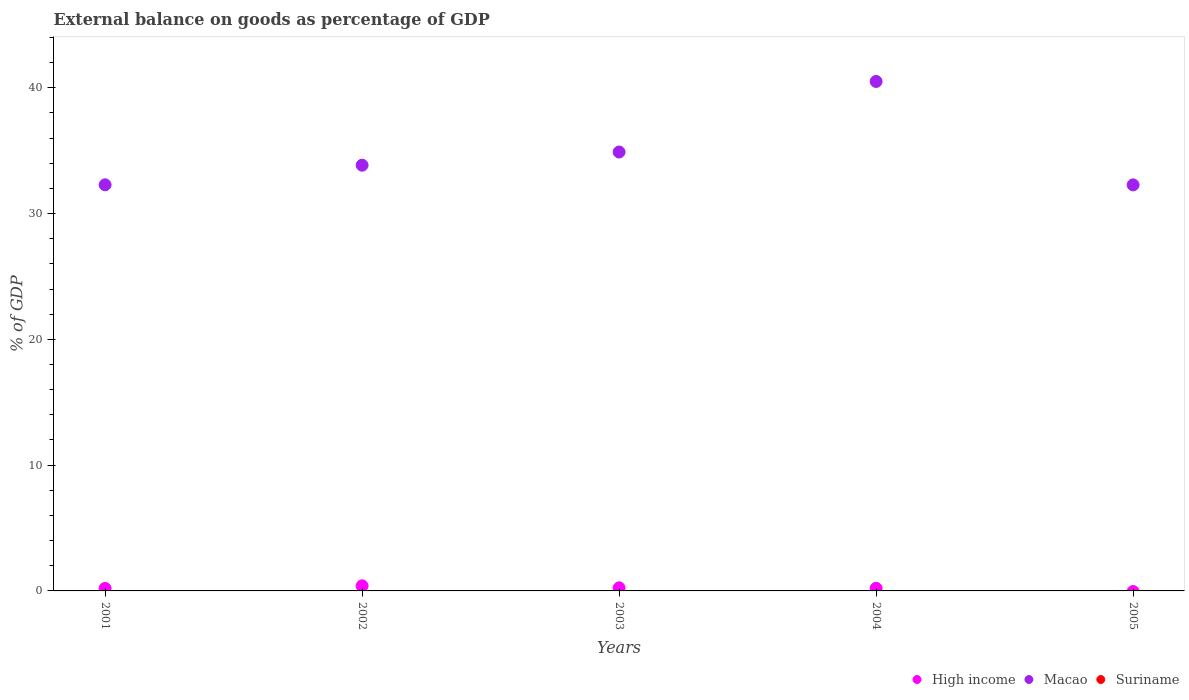Is the number of dotlines equal to the number of legend labels?
Your answer should be compact. No. What is the external balance on goods as percentage of GDP in Macao in 2001?
Offer a very short reply. 32.28. Across all years, what is the maximum external balance on goods as percentage of GDP in Macao?
Offer a very short reply. 40.5. Across all years, what is the minimum external balance on goods as percentage of GDP in High income?
Ensure brevity in your answer.  0. In which year was the external balance on goods as percentage of GDP in Macao maximum?
Provide a short and direct response. 2004. What is the total external balance on goods as percentage of GDP in High income in the graph?
Keep it short and to the point. 1.05. What is the difference between the external balance on goods as percentage of GDP in Macao in 2001 and that in 2005?
Offer a very short reply. 0.01. What is the difference between the external balance on goods as percentage of GDP in Macao in 2004 and the external balance on goods as percentage of GDP in Suriname in 2003?
Provide a succinct answer. 40.5. What is the average external balance on goods as percentage of GDP in Macao per year?
Provide a succinct answer. 34.76. In the year 2003, what is the difference between the external balance on goods as percentage of GDP in Macao and external balance on goods as percentage of GDP in High income?
Provide a short and direct response. 34.65. In how many years, is the external balance on goods as percentage of GDP in Macao greater than 32 %?
Your response must be concise. 5. What is the ratio of the external balance on goods as percentage of GDP in Macao in 2001 to that in 2003?
Offer a terse response. 0.93. Is the difference between the external balance on goods as percentage of GDP in Macao in 2002 and 2003 greater than the difference between the external balance on goods as percentage of GDP in High income in 2002 and 2003?
Your answer should be compact. No. What is the difference between the highest and the second highest external balance on goods as percentage of GDP in Macao?
Your answer should be compact. 5.61. What is the difference between the highest and the lowest external balance on goods as percentage of GDP in High income?
Your response must be concise. 0.4. Is the external balance on goods as percentage of GDP in Macao strictly less than the external balance on goods as percentage of GDP in Suriname over the years?
Ensure brevity in your answer.  No. How many dotlines are there?
Give a very brief answer. 2. How many legend labels are there?
Your answer should be very brief. 3. How are the legend labels stacked?
Give a very brief answer. Horizontal. What is the title of the graph?
Ensure brevity in your answer.  External balance on goods as percentage of GDP. What is the label or title of the X-axis?
Give a very brief answer. Years. What is the label or title of the Y-axis?
Provide a succinct answer. % of GDP. What is the % of GDP of High income in 2001?
Provide a short and direct response. 0.2. What is the % of GDP in Macao in 2001?
Keep it short and to the point. 32.28. What is the % of GDP in High income in 2002?
Provide a succinct answer. 0.4. What is the % of GDP of Macao in 2002?
Your answer should be very brief. 33.84. What is the % of GDP of High income in 2003?
Make the answer very short. 0.24. What is the % of GDP in Macao in 2003?
Offer a very short reply. 34.89. What is the % of GDP of High income in 2004?
Offer a very short reply. 0.2. What is the % of GDP of Macao in 2004?
Offer a terse response. 40.5. What is the % of GDP of High income in 2005?
Your answer should be compact. 0. What is the % of GDP of Macao in 2005?
Provide a succinct answer. 32.28. Across all years, what is the maximum % of GDP of High income?
Your response must be concise. 0.4. Across all years, what is the maximum % of GDP of Macao?
Offer a terse response. 40.5. Across all years, what is the minimum % of GDP of High income?
Provide a succinct answer. 0. Across all years, what is the minimum % of GDP of Macao?
Offer a very short reply. 32.28. What is the total % of GDP of High income in the graph?
Keep it short and to the point. 1.05. What is the total % of GDP of Macao in the graph?
Ensure brevity in your answer.  173.8. What is the total % of GDP in Suriname in the graph?
Ensure brevity in your answer.  0. What is the difference between the % of GDP in High income in 2001 and that in 2002?
Keep it short and to the point. -0.21. What is the difference between the % of GDP in Macao in 2001 and that in 2002?
Make the answer very short. -1.56. What is the difference between the % of GDP in High income in 2001 and that in 2003?
Your answer should be compact. -0.05. What is the difference between the % of GDP of Macao in 2001 and that in 2003?
Provide a short and direct response. -2.61. What is the difference between the % of GDP in High income in 2001 and that in 2004?
Ensure brevity in your answer.  -0.01. What is the difference between the % of GDP of Macao in 2001 and that in 2004?
Make the answer very short. -8.22. What is the difference between the % of GDP in Macao in 2001 and that in 2005?
Ensure brevity in your answer.  0.01. What is the difference between the % of GDP of High income in 2002 and that in 2003?
Keep it short and to the point. 0.16. What is the difference between the % of GDP of Macao in 2002 and that in 2003?
Keep it short and to the point. -1.05. What is the difference between the % of GDP of High income in 2002 and that in 2004?
Offer a terse response. 0.2. What is the difference between the % of GDP in Macao in 2002 and that in 2004?
Give a very brief answer. -6.66. What is the difference between the % of GDP in Macao in 2002 and that in 2005?
Offer a terse response. 1.56. What is the difference between the % of GDP of High income in 2003 and that in 2004?
Provide a short and direct response. 0.04. What is the difference between the % of GDP of Macao in 2003 and that in 2004?
Your answer should be compact. -5.61. What is the difference between the % of GDP of Macao in 2003 and that in 2005?
Offer a terse response. 2.61. What is the difference between the % of GDP in Macao in 2004 and that in 2005?
Offer a very short reply. 8.22. What is the difference between the % of GDP of High income in 2001 and the % of GDP of Macao in 2002?
Your response must be concise. -33.65. What is the difference between the % of GDP in High income in 2001 and the % of GDP in Macao in 2003?
Give a very brief answer. -34.69. What is the difference between the % of GDP in High income in 2001 and the % of GDP in Macao in 2004?
Offer a terse response. -40.3. What is the difference between the % of GDP in High income in 2001 and the % of GDP in Macao in 2005?
Your answer should be compact. -32.08. What is the difference between the % of GDP of High income in 2002 and the % of GDP of Macao in 2003?
Your answer should be very brief. -34.49. What is the difference between the % of GDP of High income in 2002 and the % of GDP of Macao in 2004?
Your answer should be very brief. -40.1. What is the difference between the % of GDP in High income in 2002 and the % of GDP in Macao in 2005?
Offer a terse response. -31.87. What is the difference between the % of GDP of High income in 2003 and the % of GDP of Macao in 2004?
Your answer should be compact. -40.26. What is the difference between the % of GDP of High income in 2003 and the % of GDP of Macao in 2005?
Keep it short and to the point. -32.03. What is the difference between the % of GDP of High income in 2004 and the % of GDP of Macao in 2005?
Your answer should be compact. -32.07. What is the average % of GDP in High income per year?
Make the answer very short. 0.21. What is the average % of GDP in Macao per year?
Your response must be concise. 34.76. What is the average % of GDP of Suriname per year?
Make the answer very short. 0. In the year 2001, what is the difference between the % of GDP in High income and % of GDP in Macao?
Give a very brief answer. -32.09. In the year 2002, what is the difference between the % of GDP in High income and % of GDP in Macao?
Offer a terse response. -33.44. In the year 2003, what is the difference between the % of GDP in High income and % of GDP in Macao?
Offer a very short reply. -34.65. In the year 2004, what is the difference between the % of GDP in High income and % of GDP in Macao?
Provide a succinct answer. -40.3. What is the ratio of the % of GDP of High income in 2001 to that in 2002?
Offer a terse response. 0.49. What is the ratio of the % of GDP in Macao in 2001 to that in 2002?
Your response must be concise. 0.95. What is the ratio of the % of GDP in High income in 2001 to that in 2003?
Offer a terse response. 0.81. What is the ratio of the % of GDP in Macao in 2001 to that in 2003?
Provide a succinct answer. 0.93. What is the ratio of the % of GDP in High income in 2001 to that in 2004?
Make the answer very short. 0.97. What is the ratio of the % of GDP of Macao in 2001 to that in 2004?
Offer a very short reply. 0.8. What is the ratio of the % of GDP in High income in 2002 to that in 2003?
Make the answer very short. 1.65. What is the ratio of the % of GDP of Macao in 2002 to that in 2003?
Your response must be concise. 0.97. What is the ratio of the % of GDP in High income in 2002 to that in 2004?
Provide a short and direct response. 1.98. What is the ratio of the % of GDP of Macao in 2002 to that in 2004?
Offer a terse response. 0.84. What is the ratio of the % of GDP in Macao in 2002 to that in 2005?
Your answer should be compact. 1.05. What is the ratio of the % of GDP of High income in 2003 to that in 2004?
Your answer should be compact. 1.2. What is the ratio of the % of GDP in Macao in 2003 to that in 2004?
Give a very brief answer. 0.86. What is the ratio of the % of GDP in Macao in 2003 to that in 2005?
Offer a very short reply. 1.08. What is the ratio of the % of GDP of Macao in 2004 to that in 2005?
Provide a short and direct response. 1.25. What is the difference between the highest and the second highest % of GDP in High income?
Provide a short and direct response. 0.16. What is the difference between the highest and the second highest % of GDP of Macao?
Keep it short and to the point. 5.61. What is the difference between the highest and the lowest % of GDP in High income?
Provide a short and direct response. 0.4. What is the difference between the highest and the lowest % of GDP of Macao?
Ensure brevity in your answer.  8.22. 